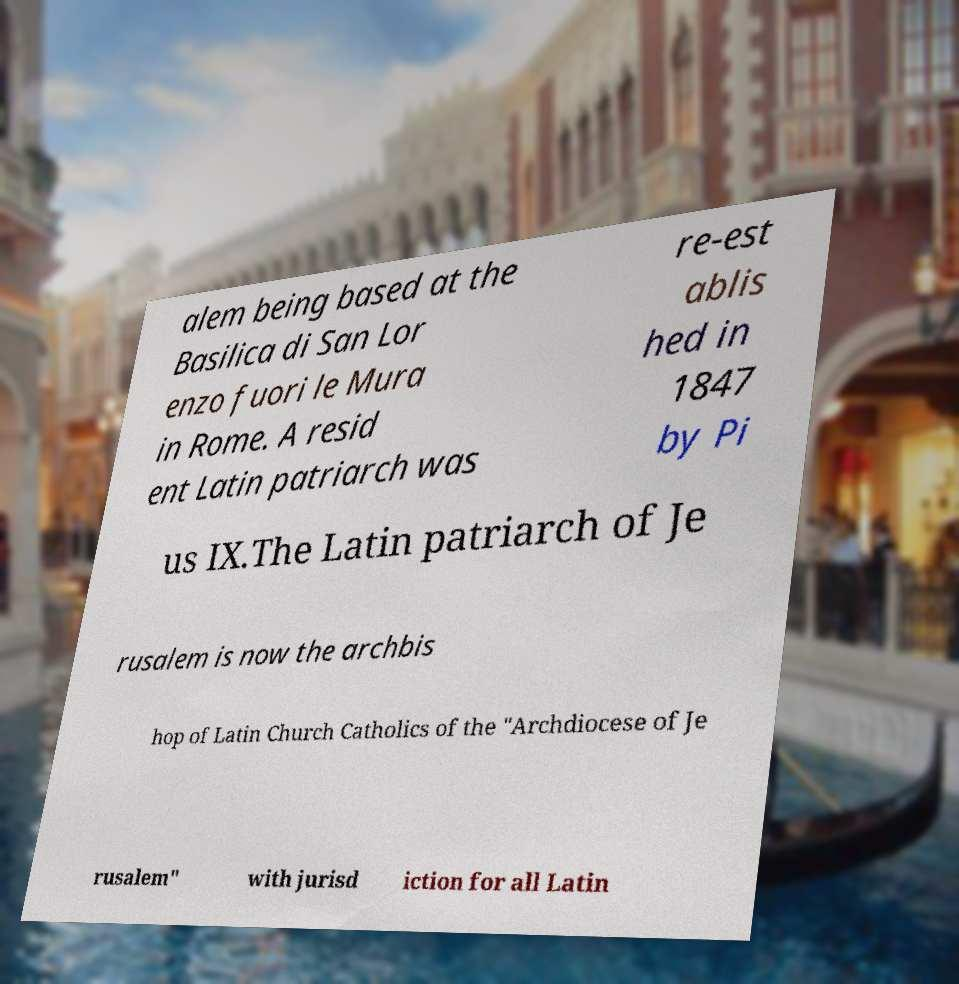Could you assist in decoding the text presented in this image and type it out clearly? alem being based at the Basilica di San Lor enzo fuori le Mura in Rome. A resid ent Latin patriarch was re-est ablis hed in 1847 by Pi us IX.The Latin patriarch of Je rusalem is now the archbis hop of Latin Church Catholics of the "Archdiocese of Je rusalem" with jurisd iction for all Latin 